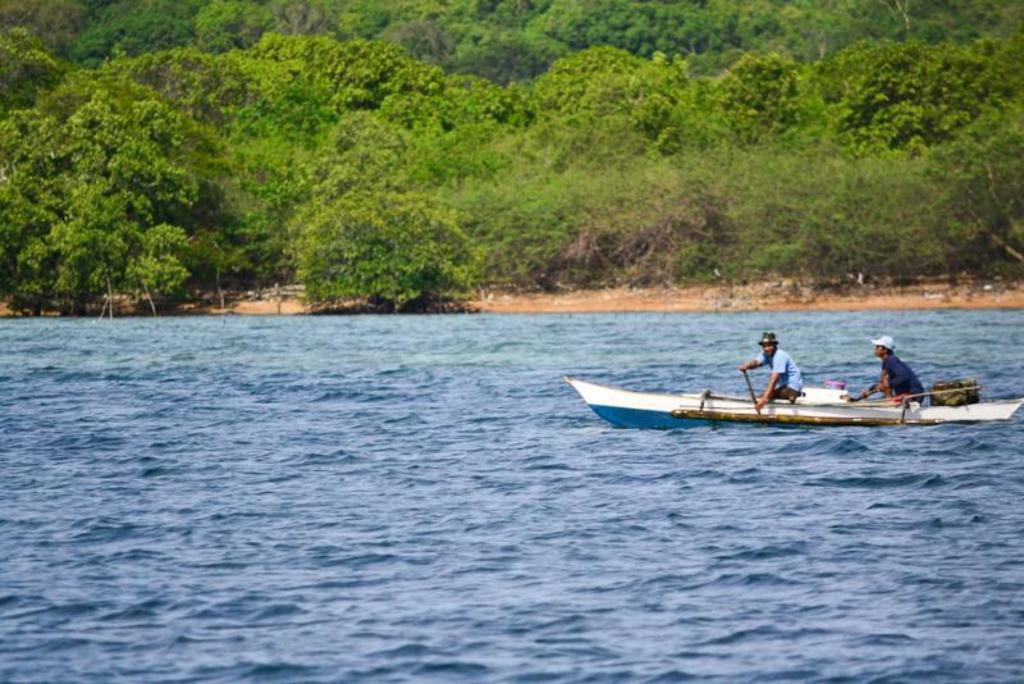Could you give a brief overview of what you see in this image? In this image I can see the water, a boat which is blue and white in color on the water and few persons on the boat. In the background I can see the ground and few trees. 